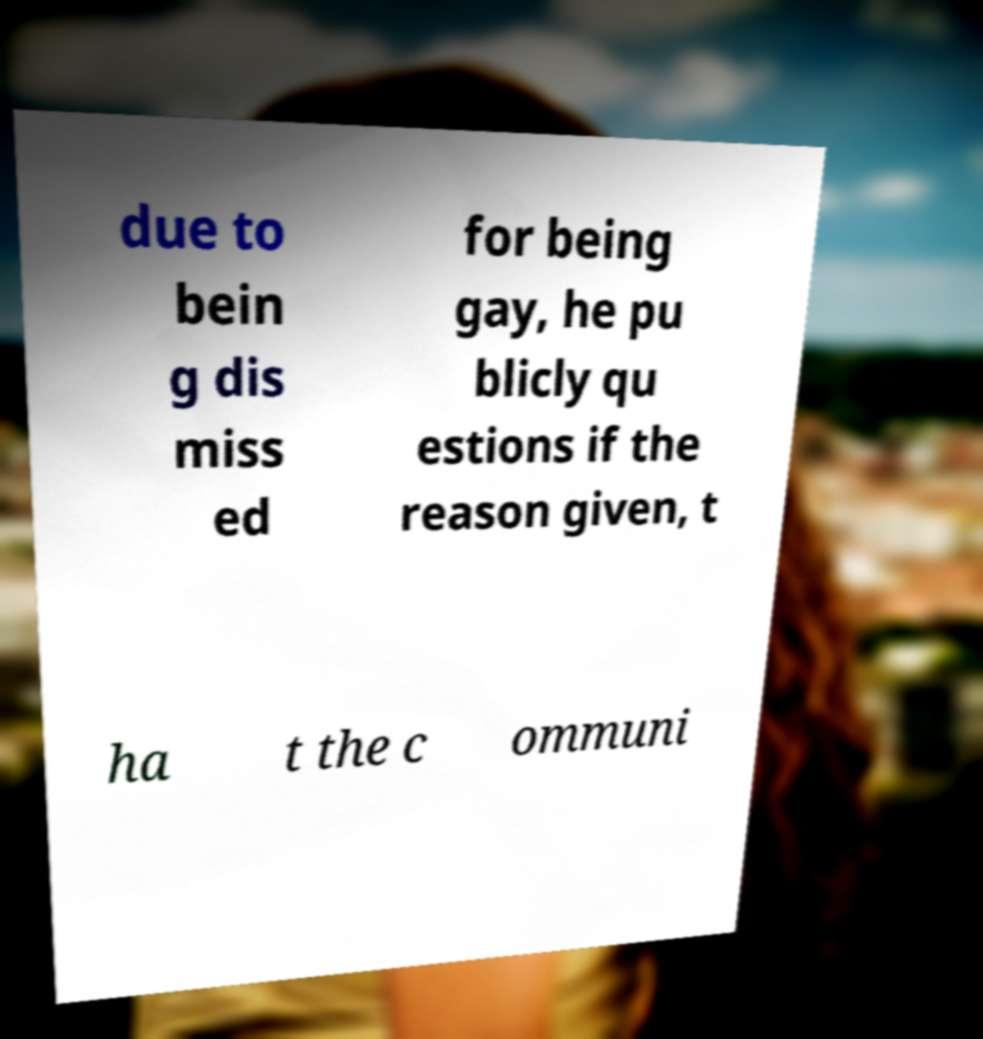Please identify and transcribe the text found in this image. due to bein g dis miss ed for being gay, he pu blicly qu estions if the reason given, t ha t the c ommuni 